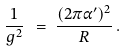<formula> <loc_0><loc_0><loc_500><loc_500>\frac { 1 } { g ^ { 2 } } \ & = \ \frac { ( 2 \pi \alpha ^ { \prime } ) ^ { 2 } } { R } \, .</formula> 